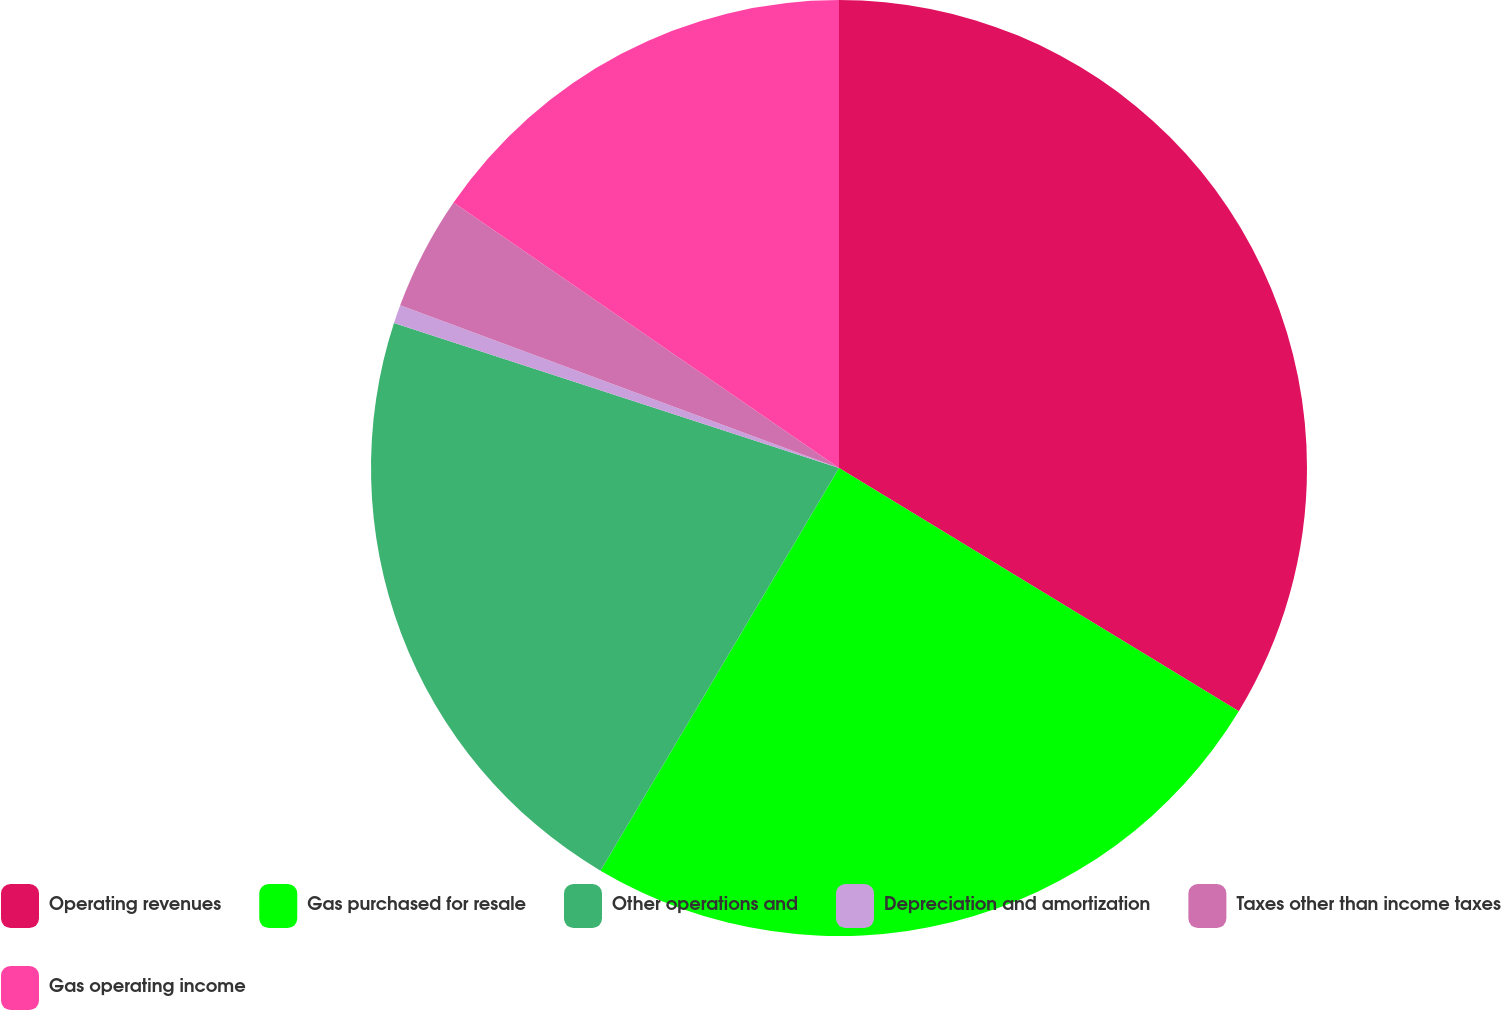Convert chart to OTSL. <chart><loc_0><loc_0><loc_500><loc_500><pie_chart><fcel>Operating revenues<fcel>Gas purchased for resale<fcel>Other operations and<fcel>Depreciation and amortization<fcel>Taxes other than income taxes<fcel>Gas operating income<nl><fcel>33.7%<fcel>24.81%<fcel>21.5%<fcel>0.64%<fcel>3.95%<fcel>15.4%<nl></chart> 